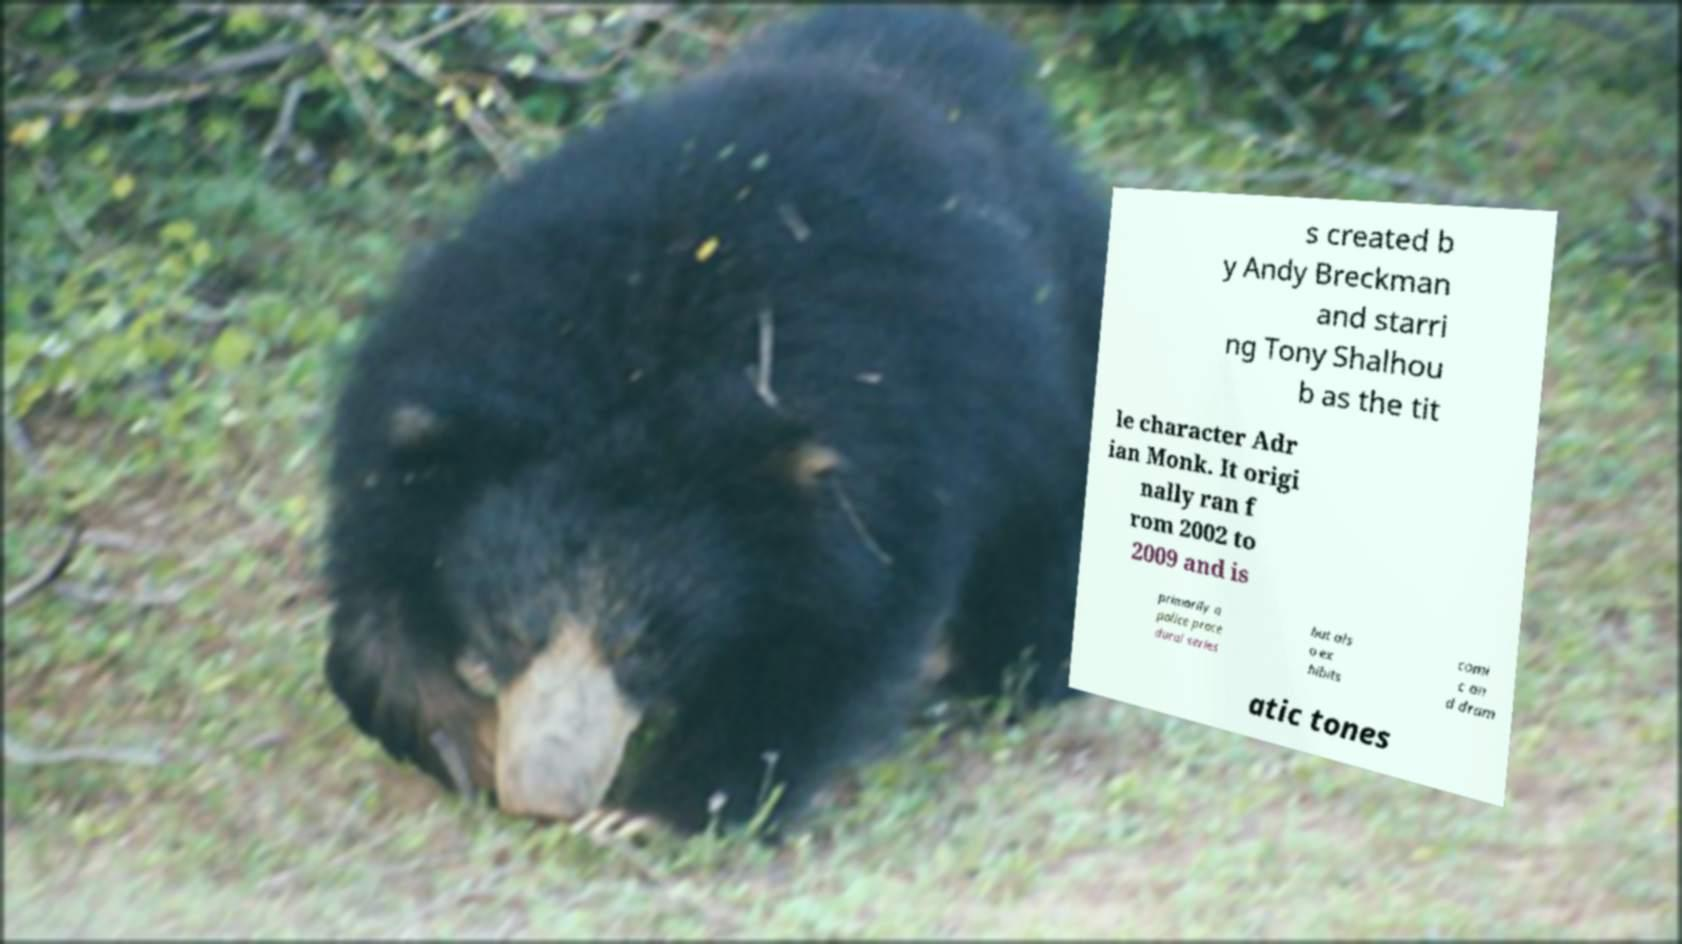What messages or text are displayed in this image? I need them in a readable, typed format. s created b y Andy Breckman and starri ng Tony Shalhou b as the tit le character Adr ian Monk. It origi nally ran f rom 2002 to 2009 and is primarily a police proce dural series but als o ex hibits comi c an d dram atic tones 